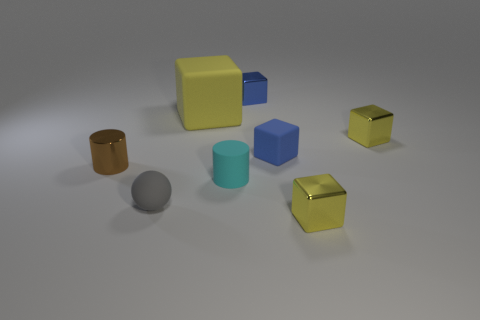Subtract all purple cylinders. How many yellow blocks are left? 3 Subtract all blue cubes. How many cubes are left? 3 Subtract all small rubber blocks. How many blocks are left? 4 Subtract all red blocks. Subtract all purple cylinders. How many blocks are left? 5 Add 1 yellow blocks. How many objects exist? 9 Subtract all blocks. How many objects are left? 3 Add 3 small cyan metallic spheres. How many small cyan metallic spheres exist? 3 Subtract 0 cyan balls. How many objects are left? 8 Subtract all small gray rubber cylinders. Subtract all yellow blocks. How many objects are left? 5 Add 4 spheres. How many spheres are left? 5 